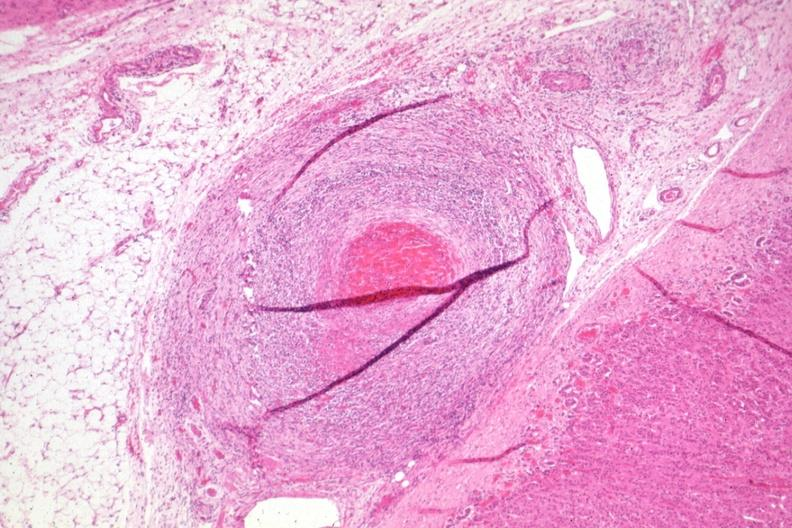what has healing lesion in medium size artery just outside adrenal capsule section?
Answer the question using a single word or phrase. Folds 